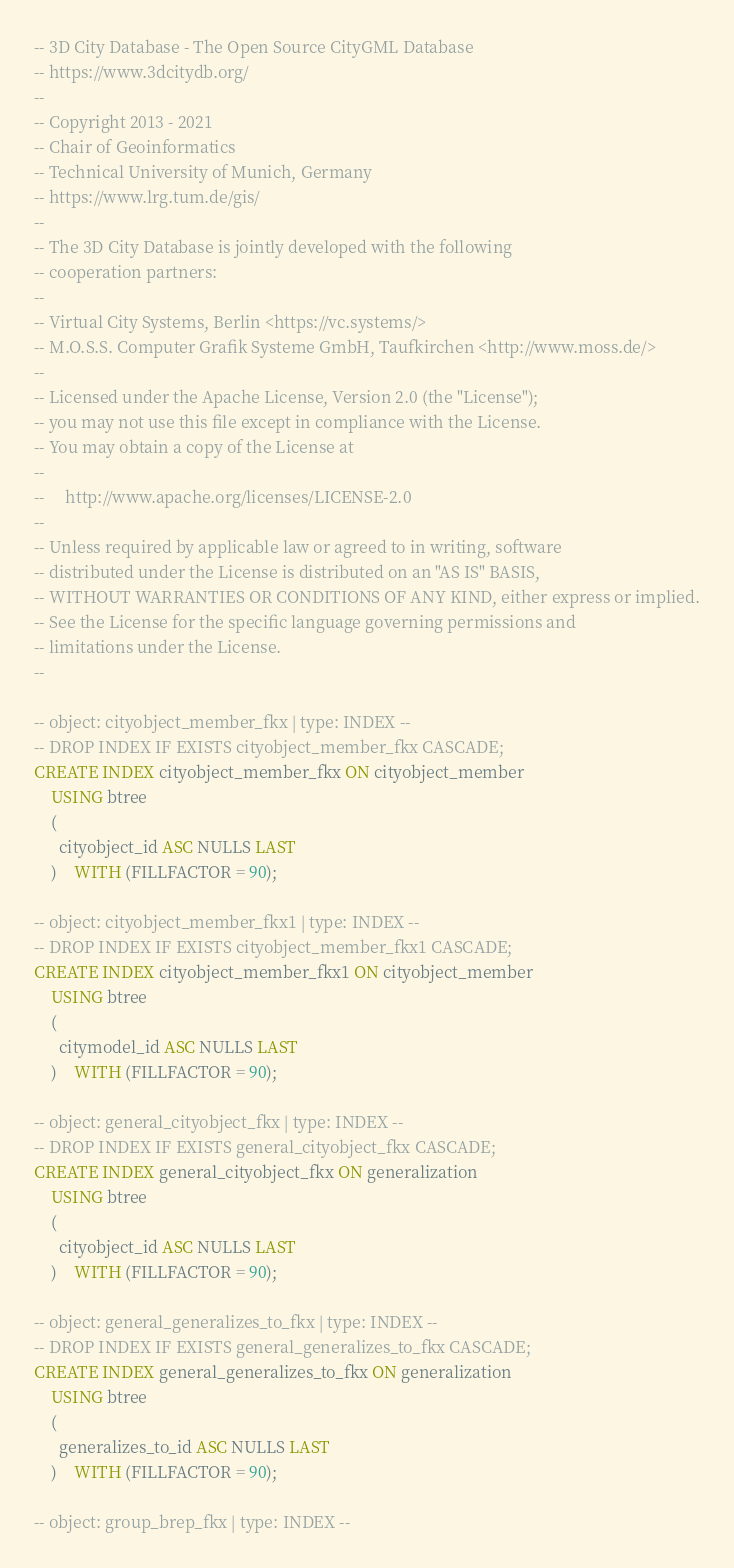Convert code to text. <code><loc_0><loc_0><loc_500><loc_500><_SQL_>-- 3D City Database - The Open Source CityGML Database
-- https://www.3dcitydb.org/
--
-- Copyright 2013 - 2021
-- Chair of Geoinformatics
-- Technical University of Munich, Germany
-- https://www.lrg.tum.de/gis/
--
-- The 3D City Database is jointly developed with the following
-- cooperation partners:
--
-- Virtual City Systems, Berlin <https://vc.systems/>
-- M.O.S.S. Computer Grafik Systeme GmbH, Taufkirchen <http://www.moss.de/>
--
-- Licensed under the Apache License, Version 2.0 (the "License");
-- you may not use this file except in compliance with the License.
-- You may obtain a copy of the License at
--
--     http://www.apache.org/licenses/LICENSE-2.0
--
-- Unless required by applicable law or agreed to in writing, software
-- distributed under the License is distributed on an "AS IS" BASIS,
-- WITHOUT WARRANTIES OR CONDITIONS OF ANY KIND, either express or implied.
-- See the License for the specific language governing permissions and
-- limitations under the License.
--

-- object: cityobject_member_fkx | type: INDEX --
-- DROP INDEX IF EXISTS cityobject_member_fkx CASCADE;
CREATE INDEX cityobject_member_fkx ON cityobject_member
	USING btree
	(
	  cityobject_id ASC NULLS LAST
	)	WITH (FILLFACTOR = 90);

-- object: cityobject_member_fkx1 | type: INDEX --
-- DROP INDEX IF EXISTS cityobject_member_fkx1 CASCADE;
CREATE INDEX cityobject_member_fkx1 ON cityobject_member
	USING btree
	(
	  citymodel_id ASC NULLS LAST
	)	WITH (FILLFACTOR = 90);

-- object: general_cityobject_fkx | type: INDEX --
-- DROP INDEX IF EXISTS general_cityobject_fkx CASCADE;
CREATE INDEX general_cityobject_fkx ON generalization
	USING btree
	(
	  cityobject_id ASC NULLS LAST
	)	WITH (FILLFACTOR = 90);

-- object: general_generalizes_to_fkx | type: INDEX --
-- DROP INDEX IF EXISTS general_generalizes_to_fkx CASCADE;
CREATE INDEX general_generalizes_to_fkx ON generalization
	USING btree
	(
	  generalizes_to_id ASC NULLS LAST
	)	WITH (FILLFACTOR = 90);

-- object: group_brep_fkx | type: INDEX --</code> 